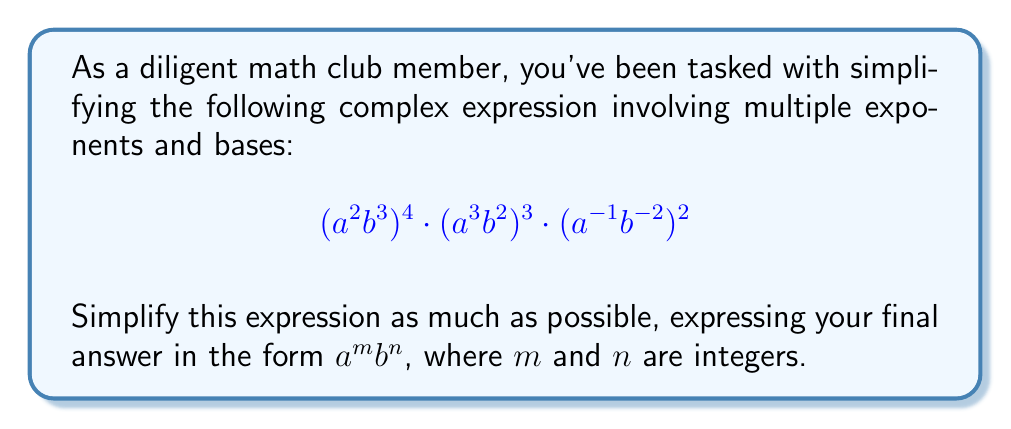Can you answer this question? Let's approach this step-by-step:

1) First, let's distribute the outer exponents:

   $$(a^2b^3)^4 = a^{2\cdot4}b^{3\cdot4} = a^8b^{12}$$
   $$(a^3b^2)^3 = a^{3\cdot3}b^{2\cdot3} = a^9b^6$$
   $$(a^{-1}b^{-2})^2 = a^{-1\cdot2}b^{-2\cdot2} = a^{-2}b^{-4}$$

2) Now our expression looks like this:

   $$a^8b^{12} \cdot a^9b^6 \cdot a^{-2}b^{-4}$$

3) When multiplying terms with the same base, we add the exponents:

   For $a$: $8 + 9 + (-2) = 15$
   For $b$: $12 + 6 + (-4) = 14$

4) Therefore, our simplified expression is:

   $$a^{15}b^{14}$$

This is already in the form $a^m b^n$ where $m$ and $n$ are integers.
Answer: $a^{15}b^{14}$ 